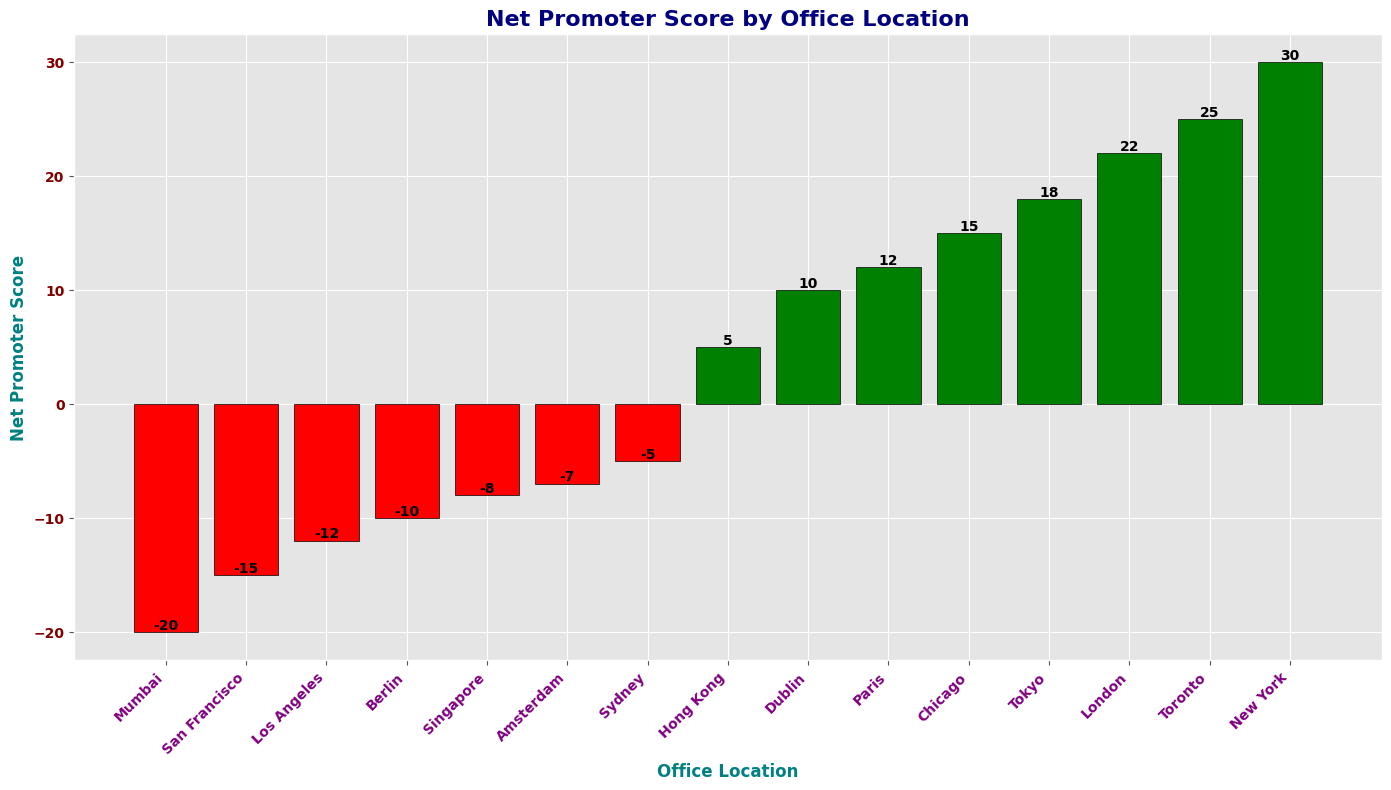Which office location has the highest Net Promoter Score? The green bar with the highest height represents the office location with the highest Net Promoter Score. Toronto's bar is the highest among the green bars.
Answer: Toronto Which office location has the lowest Net Promoter Score? The red bar with the lowest height represents the office location with the lowest Net Promoter Score. Mumbai's bar is the lowest among all the red bars.
Answer: Mumbai What is the Net Promoter Score difference between New York and San Francisco? New York's score is 30, and San Francisco's score is -15. The difference is calculated by subtracting San Francisco's score from New York's score: 30 - (-15) = 30 + 15 = 45.
Answer: 45 How many office locations have a positive Net Promoter Score? Count the number of green bars in the chart. There are 9 green bars representing positive Net Promoter Scores.
Answer: 9 Which office location has a Net Promoter Score closest to zero? Identify the bar (either red or green) that is closest in height to the zero point on the y-axis. Hong Kong's bar with a score of 5 is closest to zero.
Answer: Hong Kong How does the Net Promoter Score of London compare to Tokyo? Locate the bars for London and Tokyo and compare their heights. London's score is 22, and Tokyo's score is 18, so London has a higher score than Tokyo.
Answer: London What is the average Net Promoter Score of the top 3 office locations? Identify the top 3 office locations by their scores: New York (30), Toronto (25), and London (22). Calculate the average: (30 + 25 + 22) / 3 = 77 / 3 = 25.67.
Answer: 25.67 What is the sum of the Net Promoter Scores of the office locations in San Francisco, Berlin, and Sydney? Identify the scores: San Francisco (-15), Berlin (-10), and Sydney (-5). Sum them: -15 + (-10) + (-5) = -30.
Answer: -30 Which office location has a higher Net Promoter Score: Amsterdam or Dublin? Locate the bars for Amsterdam and Dublin and compare their heights. Amsterdam's score is -7, and Dublin's score is 10, so Dublin has a higher score.
Answer: Dublin What is the Net Promoter Score range of the office locations? Identify the highest score (New York, 30) and the lowest score (Mumbai, -20). Subtract the lowest score from the highest: 30 - (-20) = 30 + 20 = 50.
Answer: 50 